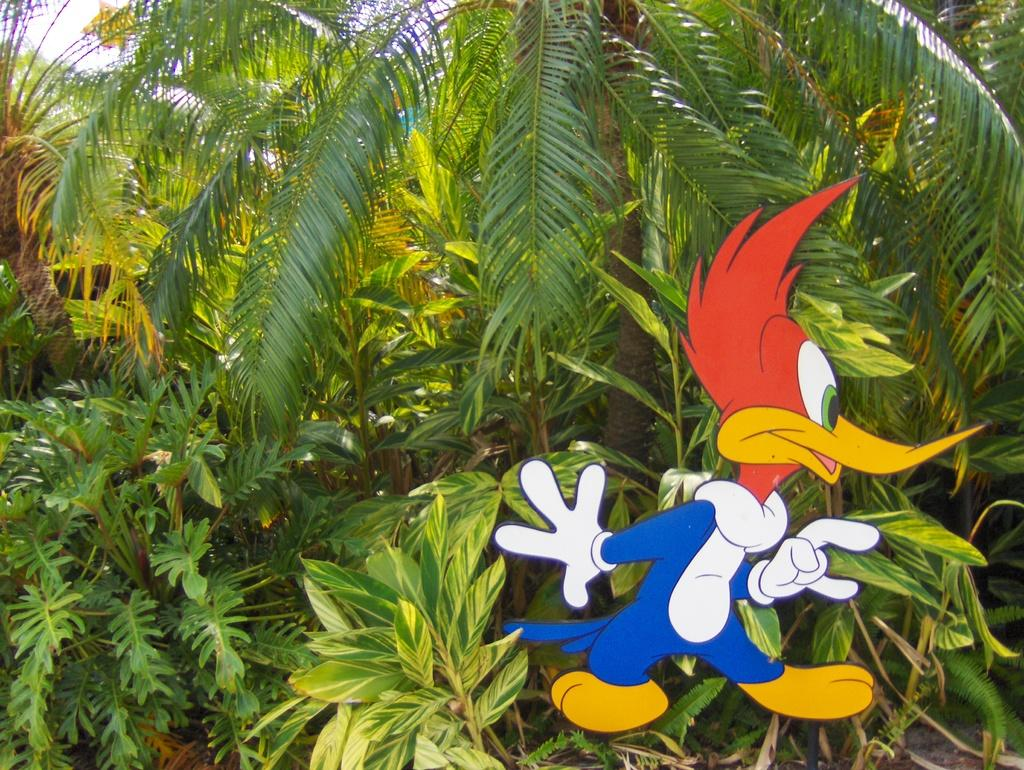What type of image is depicted in the picture? There is a picture of a cartoon in the image. What can be seen in the background of the image? There are trees in the background of the image. How does the giraffe sort the steel in the image? There is no giraffe or steel present in the image. 